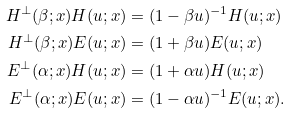<formula> <loc_0><loc_0><loc_500><loc_500>H ^ { \perp } ( \beta ; x ) H ( u ; x ) & = ( 1 - \beta u ) ^ { - 1 } H ( u ; x ) \\ H ^ { \perp } ( \beta ; x ) E ( u ; x ) & = ( 1 + \beta u ) E ( u ; x ) \\ E ^ { \perp } ( \alpha ; x ) H ( u ; x ) & = ( 1 + \alpha u ) H ( u ; x ) \\ E ^ { \perp } ( \alpha ; x ) E ( u ; x ) & = ( 1 - \alpha u ) ^ { - 1 } E ( u ; x ) .</formula> 